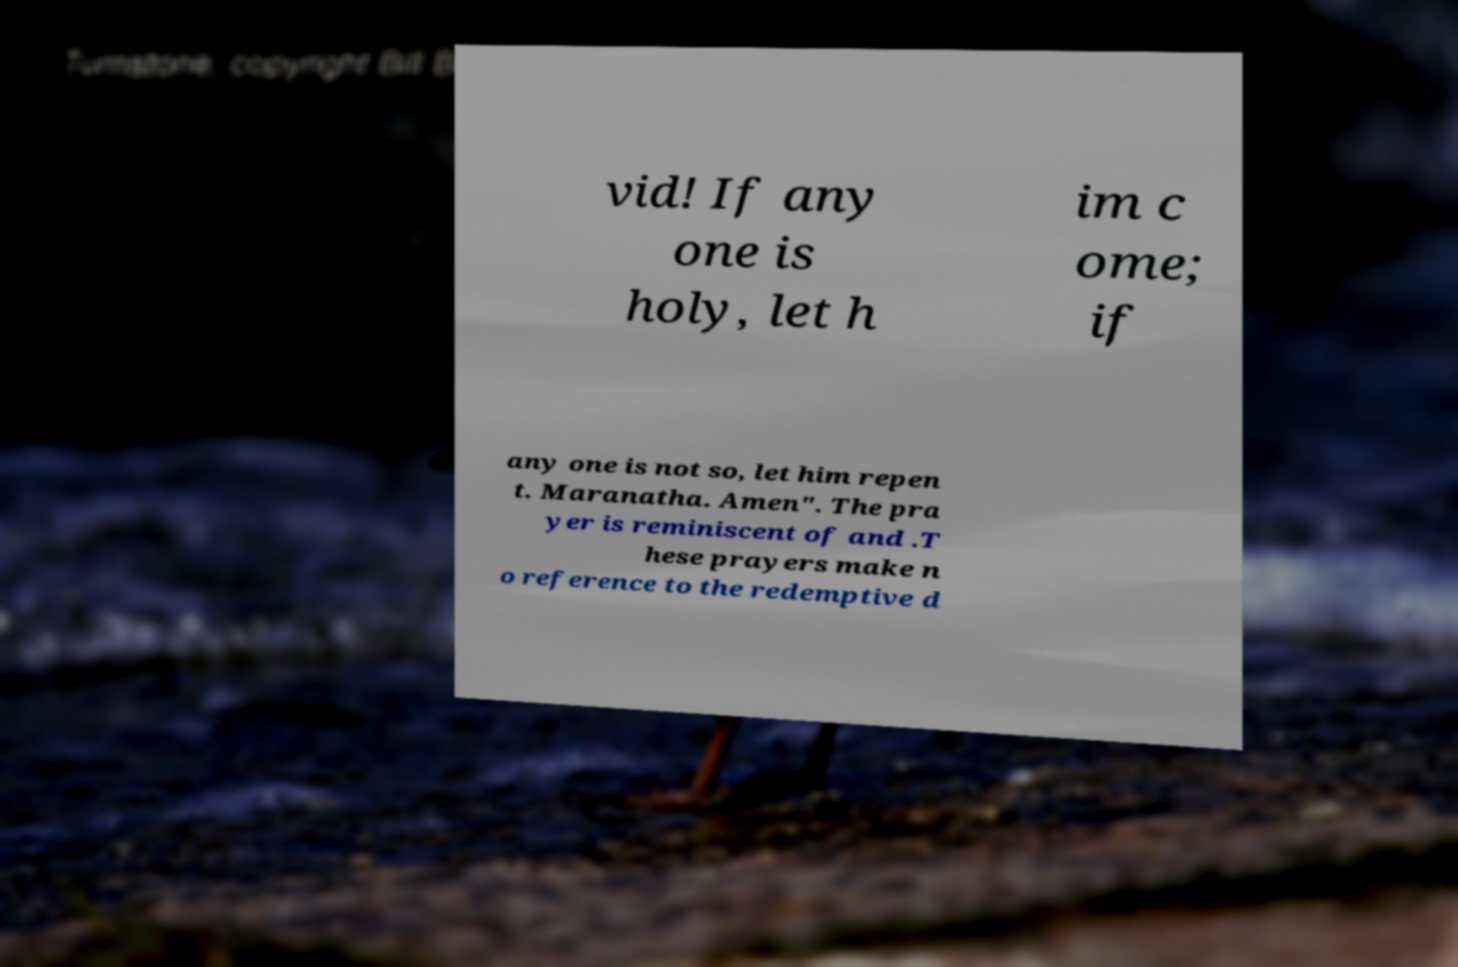What messages or text are displayed in this image? I need them in a readable, typed format. vid! If any one is holy, let h im c ome; if any one is not so, let him repen t. Maranatha. Amen". The pra yer is reminiscent of and .T hese prayers make n o reference to the redemptive d 